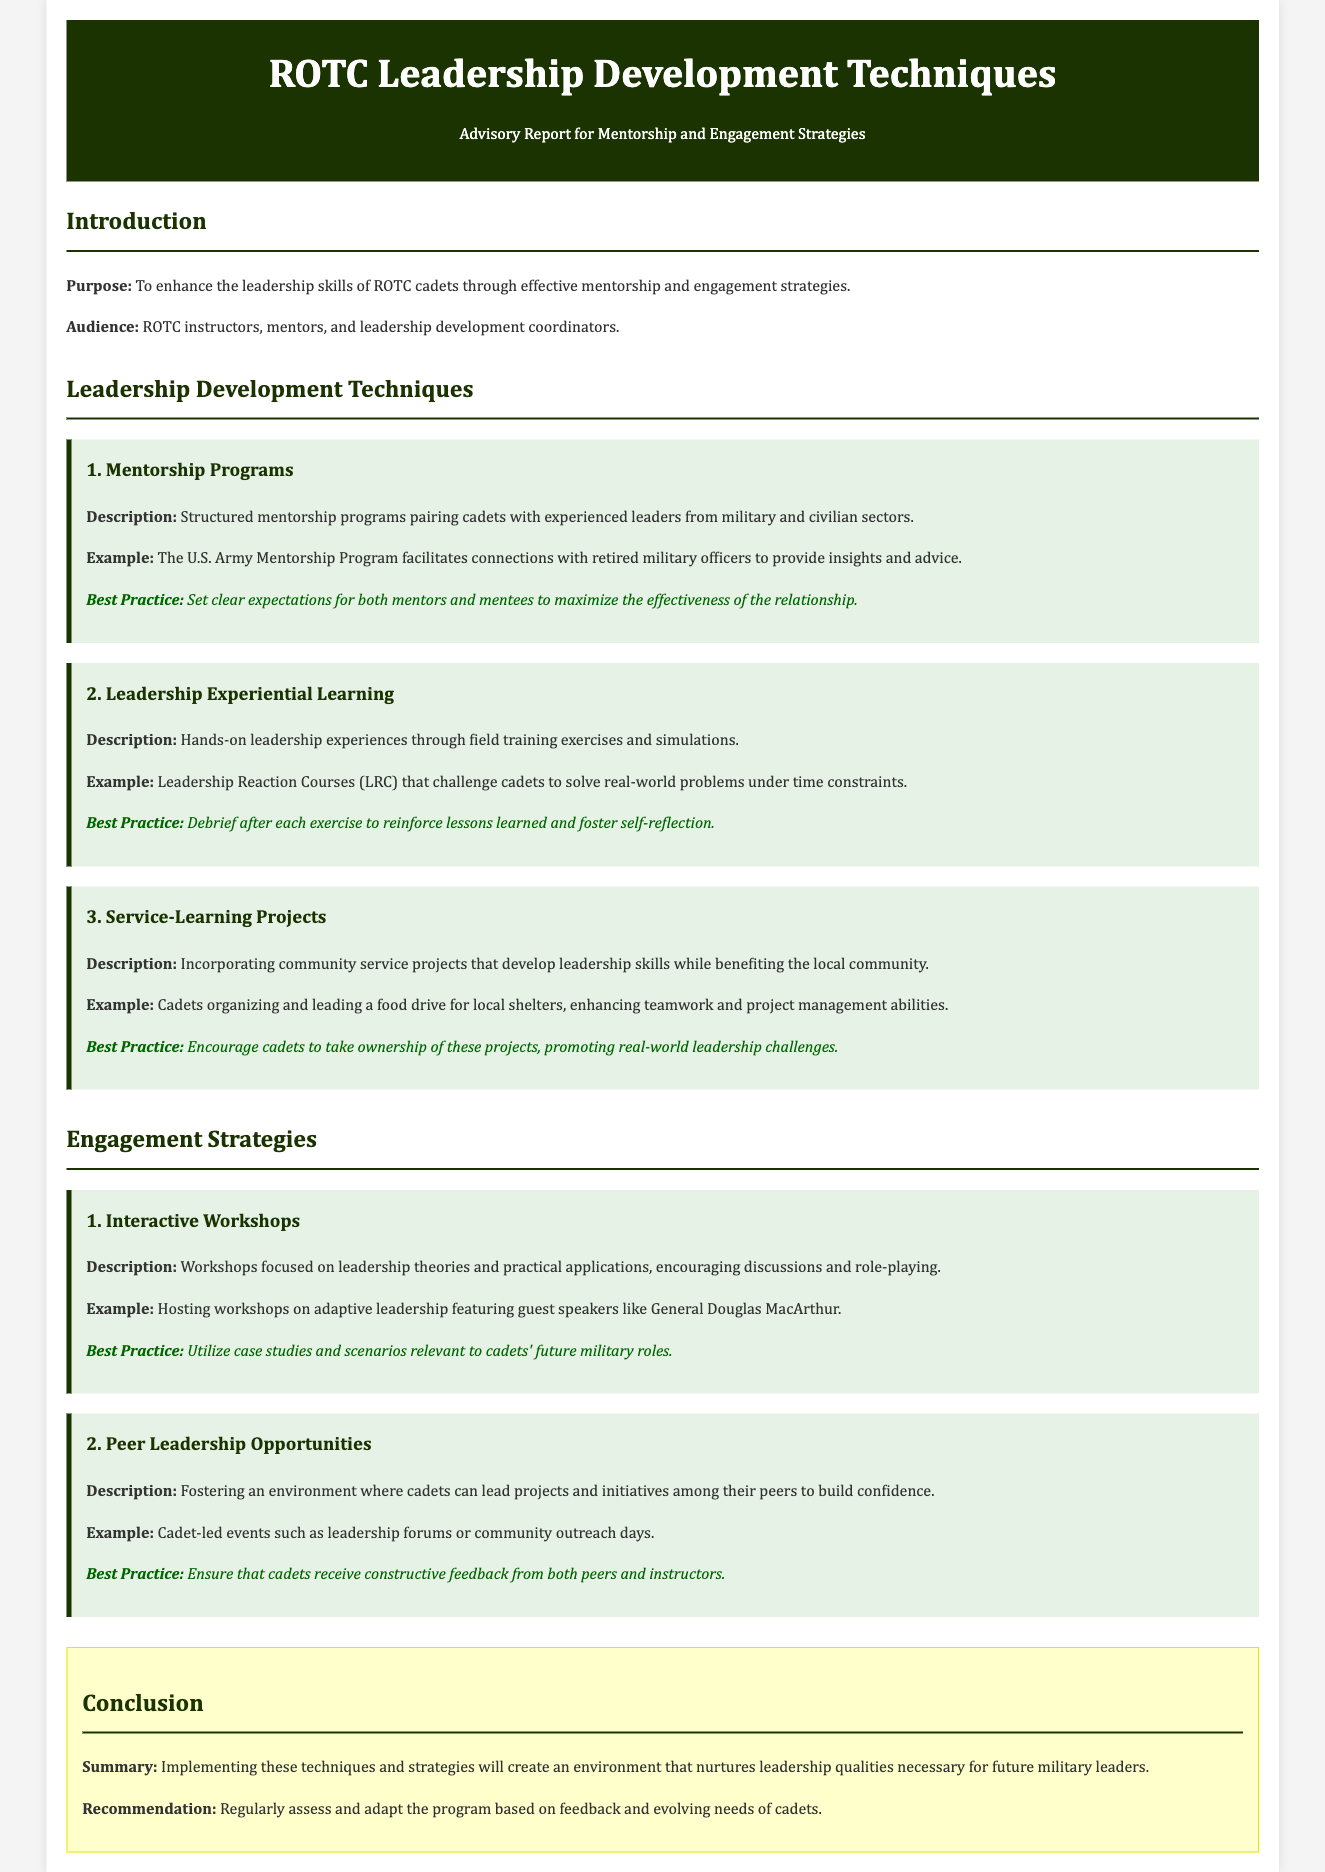what is the purpose of the report? The purpose of the report is to enhance the leadership skills of ROTC cadets through effective mentorship and engagement strategies.
Answer: enhance leadership skills of ROTC cadets who is the audience for this report? The audience for this report includes ROTC instructors, mentors, and leadership development coordinators.
Answer: ROTC instructors, mentors, and leadership development coordinators what is the first mentorship technique mentioned? The first mentorship technique mentioned is structured mentorship programs pairing cadets with experienced leaders from military and civilian sectors.
Answer: Mentorship Programs what kind of projects do service-learning projects incorporate? Service-learning projects incorporate community service projects that develop leadership skills while benefiting the local community.
Answer: community service projects what is a best practice for peer leadership opportunities? A best practice for peer leadership opportunities is to ensure that cadets receive constructive feedback from both peers and instructors.
Answer: receive constructive feedback how should cadets be encouraged during service-learning projects? Cadets should be encouraged to take ownership of these projects, promoting real-world leadership challenges.
Answer: take ownership what should be done after each leadership experiential learning experience? After each leadership experiential learning experience, a debrief should be conducted to reinforce lessons learned and foster self-reflection.
Answer: debrief what is the recommendation at the end of the report? The recommendation is to regularly assess and adapt the program based on feedback and evolving needs of cadets.
Answer: regularly assess and adapt the program 